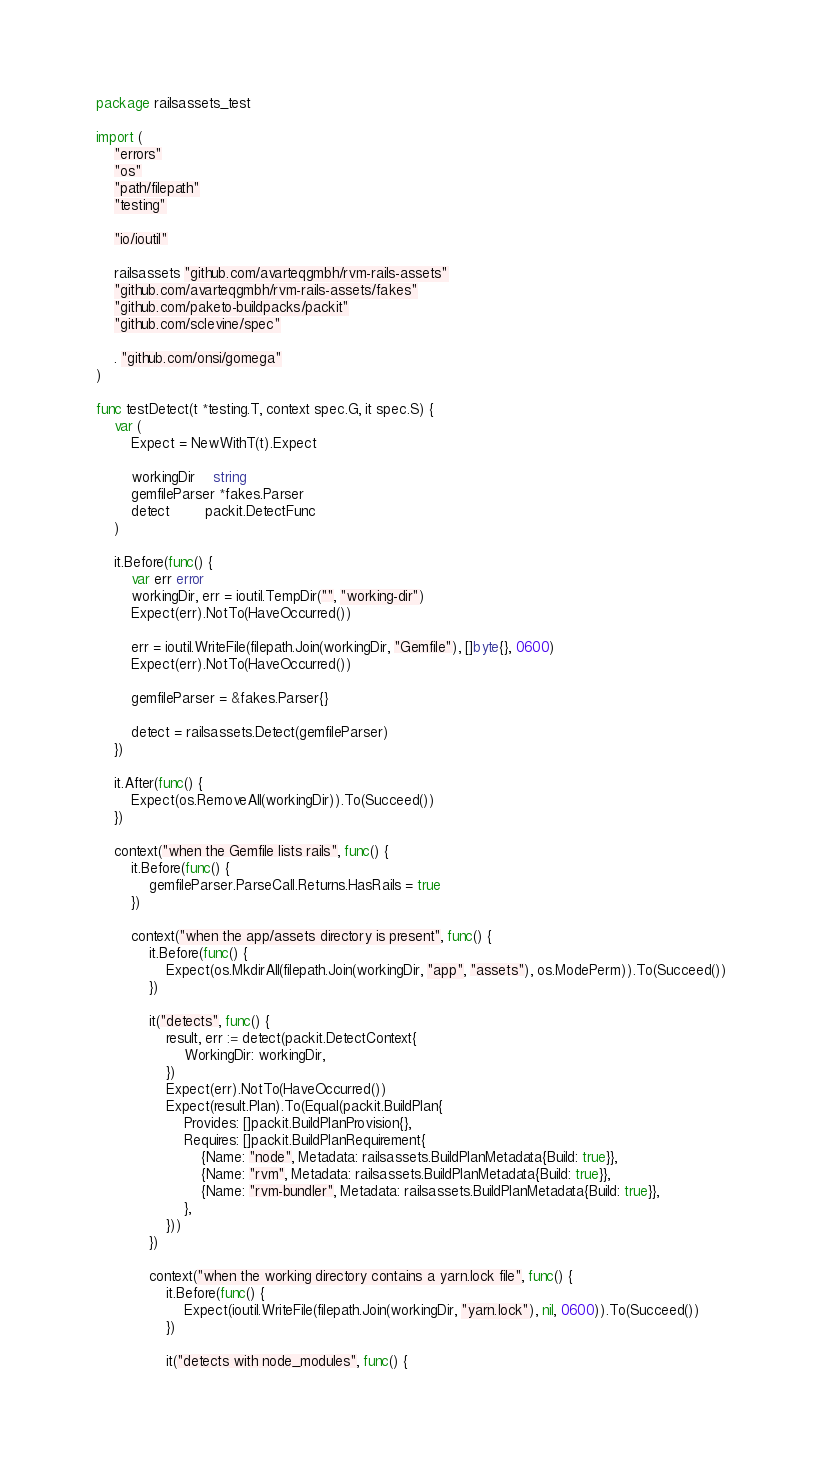Convert code to text. <code><loc_0><loc_0><loc_500><loc_500><_Go_>package railsassets_test

import (
	"errors"
	"os"
	"path/filepath"
	"testing"

	"io/ioutil"

	railsassets "github.com/avarteqgmbh/rvm-rails-assets"
	"github.com/avarteqgmbh/rvm-rails-assets/fakes"
	"github.com/paketo-buildpacks/packit"
	"github.com/sclevine/spec"

	. "github.com/onsi/gomega"
)

func testDetect(t *testing.T, context spec.G, it spec.S) {
	var (
		Expect = NewWithT(t).Expect

		workingDir    string
		gemfileParser *fakes.Parser
		detect        packit.DetectFunc
	)

	it.Before(func() {
		var err error
		workingDir, err = ioutil.TempDir("", "working-dir")
		Expect(err).NotTo(HaveOccurred())

		err = ioutil.WriteFile(filepath.Join(workingDir, "Gemfile"), []byte{}, 0600)
		Expect(err).NotTo(HaveOccurred())

		gemfileParser = &fakes.Parser{}

		detect = railsassets.Detect(gemfileParser)
	})

	it.After(func() {
		Expect(os.RemoveAll(workingDir)).To(Succeed())
	})

	context("when the Gemfile lists rails", func() {
		it.Before(func() {
			gemfileParser.ParseCall.Returns.HasRails = true
		})

		context("when the app/assets directory is present", func() {
			it.Before(func() {
				Expect(os.MkdirAll(filepath.Join(workingDir, "app", "assets"), os.ModePerm)).To(Succeed())
			})

			it("detects", func() {
				result, err := detect(packit.DetectContext{
					WorkingDir: workingDir,
				})
				Expect(err).NotTo(HaveOccurred())
				Expect(result.Plan).To(Equal(packit.BuildPlan{
					Provides: []packit.BuildPlanProvision{},
					Requires: []packit.BuildPlanRequirement{
						{Name: "node", Metadata: railsassets.BuildPlanMetadata{Build: true}},
						{Name: "rvm", Metadata: railsassets.BuildPlanMetadata{Build: true}},
						{Name: "rvm-bundler", Metadata: railsassets.BuildPlanMetadata{Build: true}},
					},
				}))
			})

			context("when the working directory contains a yarn.lock file", func() {
				it.Before(func() {
					Expect(ioutil.WriteFile(filepath.Join(workingDir, "yarn.lock"), nil, 0600)).To(Succeed())
				})

				it("detects with node_modules", func() {</code> 